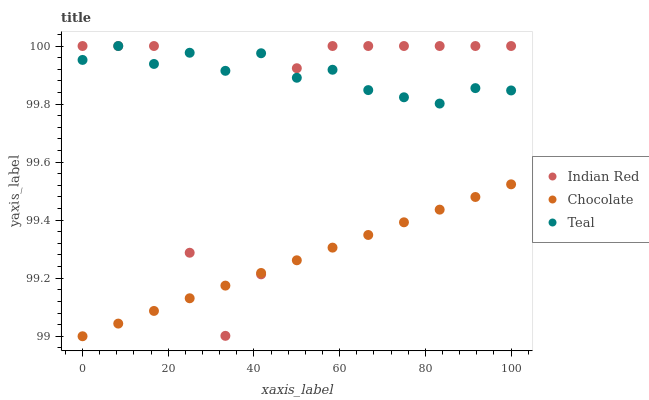Does Chocolate have the minimum area under the curve?
Answer yes or no. Yes. Does Teal have the maximum area under the curve?
Answer yes or no. Yes. Does Indian Red have the minimum area under the curve?
Answer yes or no. No. Does Indian Red have the maximum area under the curve?
Answer yes or no. No. Is Chocolate the smoothest?
Answer yes or no. Yes. Is Indian Red the roughest?
Answer yes or no. Yes. Is Indian Red the smoothest?
Answer yes or no. No. Is Chocolate the roughest?
Answer yes or no. No. Does Chocolate have the lowest value?
Answer yes or no. Yes. Does Indian Red have the lowest value?
Answer yes or no. No. Does Indian Red have the highest value?
Answer yes or no. Yes. Does Chocolate have the highest value?
Answer yes or no. No. Is Chocolate less than Teal?
Answer yes or no. Yes. Is Teal greater than Chocolate?
Answer yes or no. Yes. Does Chocolate intersect Indian Red?
Answer yes or no. Yes. Is Chocolate less than Indian Red?
Answer yes or no. No. Is Chocolate greater than Indian Red?
Answer yes or no. No. Does Chocolate intersect Teal?
Answer yes or no. No. 